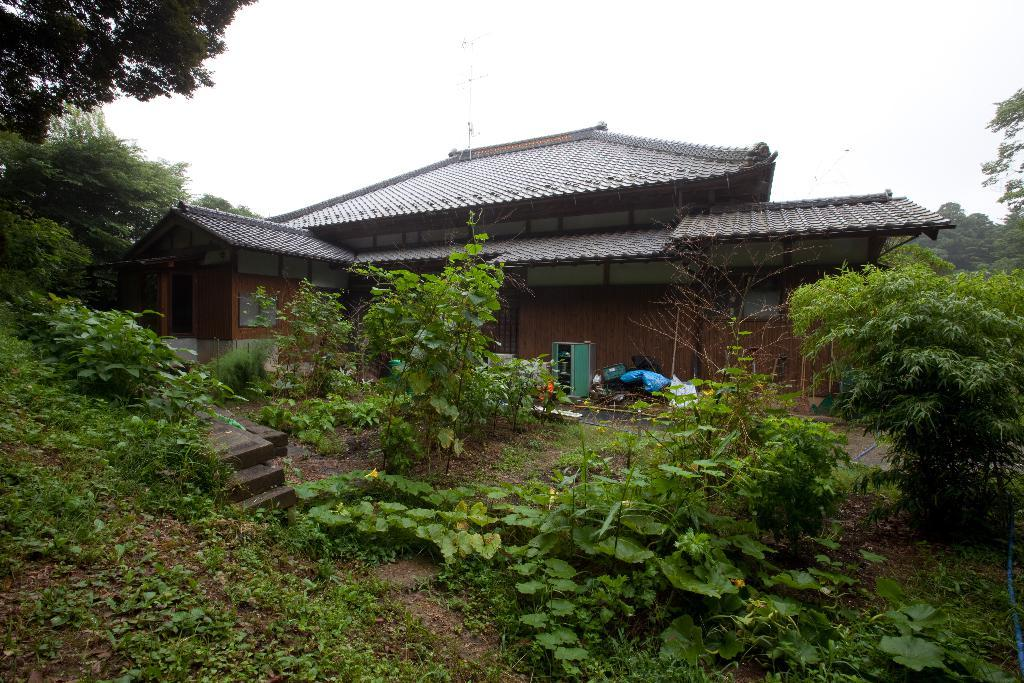What celestial bodies are present in the image? There are planets in the image. What other objects can be seen in the image besides the planets? There are objects, a house, roofs, windows, and a door visible in the image. What type of vegetation is present in the image? There are trees in the image. What part of the natural environment is visible in the image? The sky is visible in the image. How many crows are sitting on the chair in the image? There are no crows or chairs present in the image. What type of leaf is falling from the tree in the image? There are no leaves falling from the tree in the image; it only shows trees and not any specific leaf. 